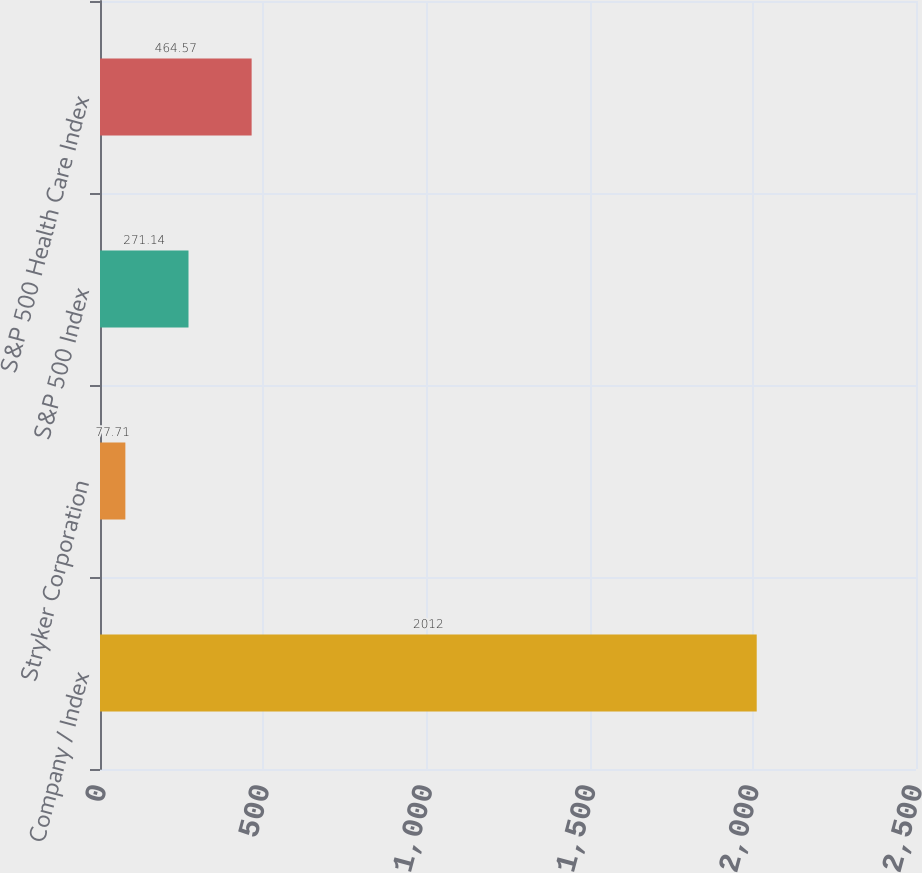<chart> <loc_0><loc_0><loc_500><loc_500><bar_chart><fcel>Company / Index<fcel>Stryker Corporation<fcel>S&P 500 Index<fcel>S&P 500 Health Care Index<nl><fcel>2012<fcel>77.71<fcel>271.14<fcel>464.57<nl></chart> 